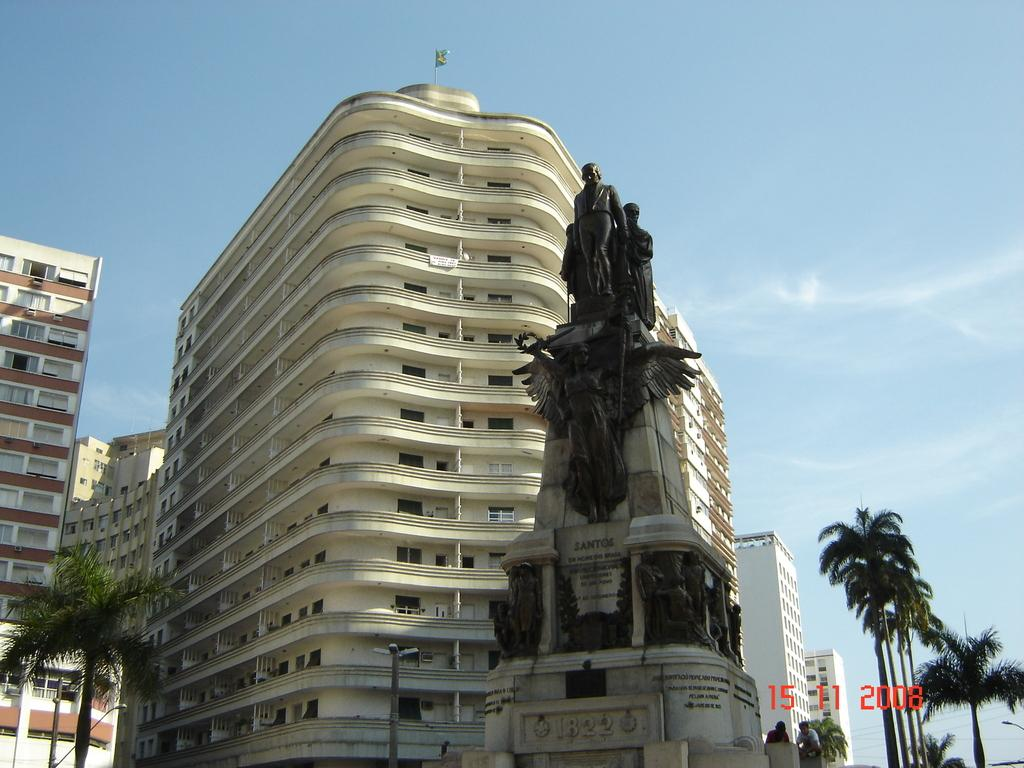<image>
Describe the image concisely. a wind swept white building with a statue in front of it taken on 15 11 2008 